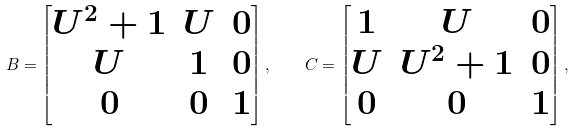Convert formula to latex. <formula><loc_0><loc_0><loc_500><loc_500>B = \begin{bmatrix} U ^ { 2 } + 1 & U & 0 \\ U & 1 & 0 \\ 0 & 0 & 1 \end{bmatrix} , \quad C = \begin{bmatrix} 1 & U & 0 \\ U & U ^ { 2 } + 1 & 0 \\ 0 & 0 & 1 \end{bmatrix} ,</formula> 